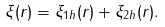Convert formula to latex. <formula><loc_0><loc_0><loc_500><loc_500>\xi ( r ) = \xi _ { 1 h } ( r ) + \xi _ { 2 h } ( r ) .</formula> 